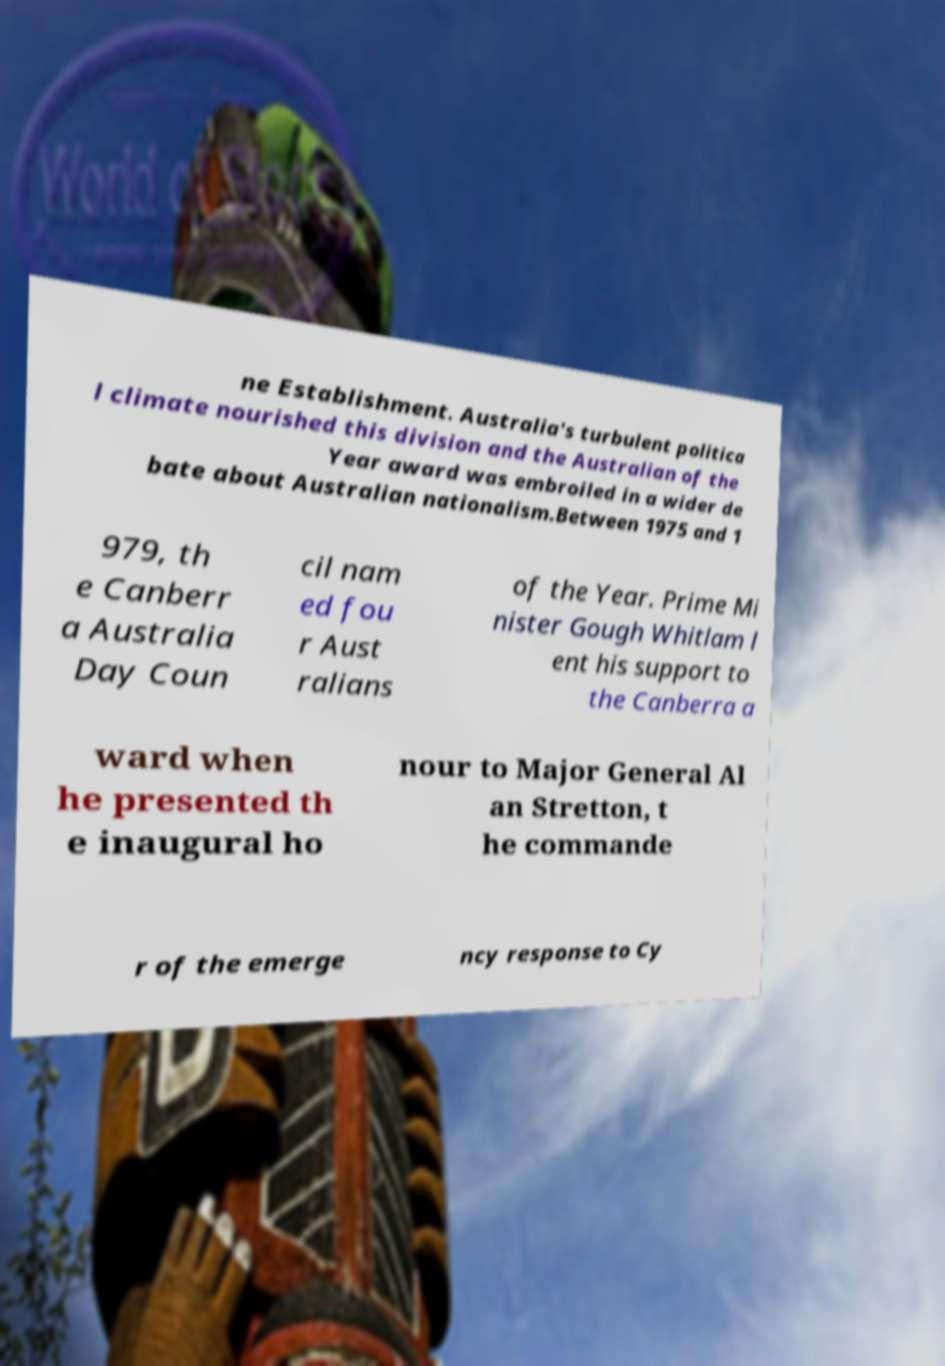For documentation purposes, I need the text within this image transcribed. Could you provide that? ne Establishment. Australia's turbulent politica l climate nourished this division and the Australian of the Year award was embroiled in a wider de bate about Australian nationalism.Between 1975 and 1 979, th e Canberr a Australia Day Coun cil nam ed fou r Aust ralians of the Year. Prime Mi nister Gough Whitlam l ent his support to the Canberra a ward when he presented th e inaugural ho nour to Major General Al an Stretton, t he commande r of the emerge ncy response to Cy 